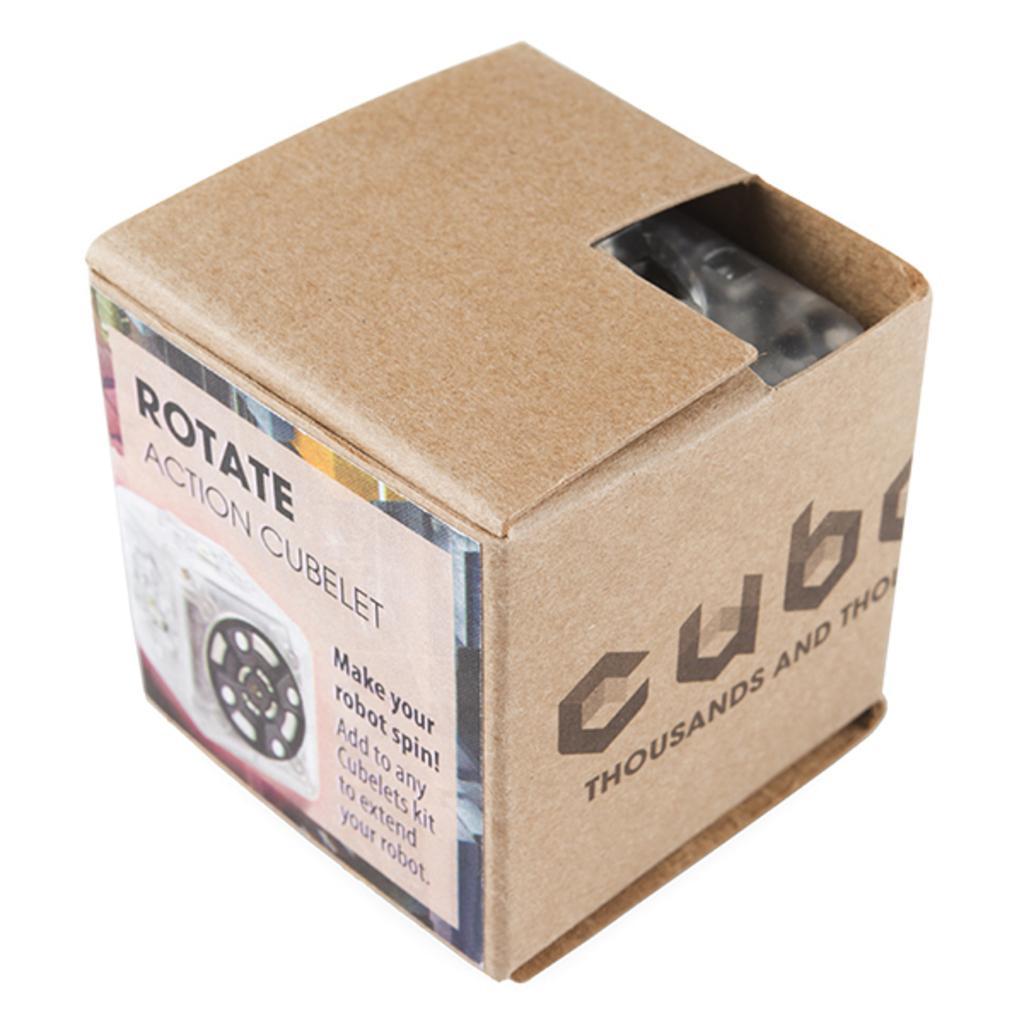Could you give a brief overview of what you see in this image? In the picture we can see a box which is in the shape of the cube and it is made up of cardboard and a label to it, on it we can see a name Rotate action cube let. 